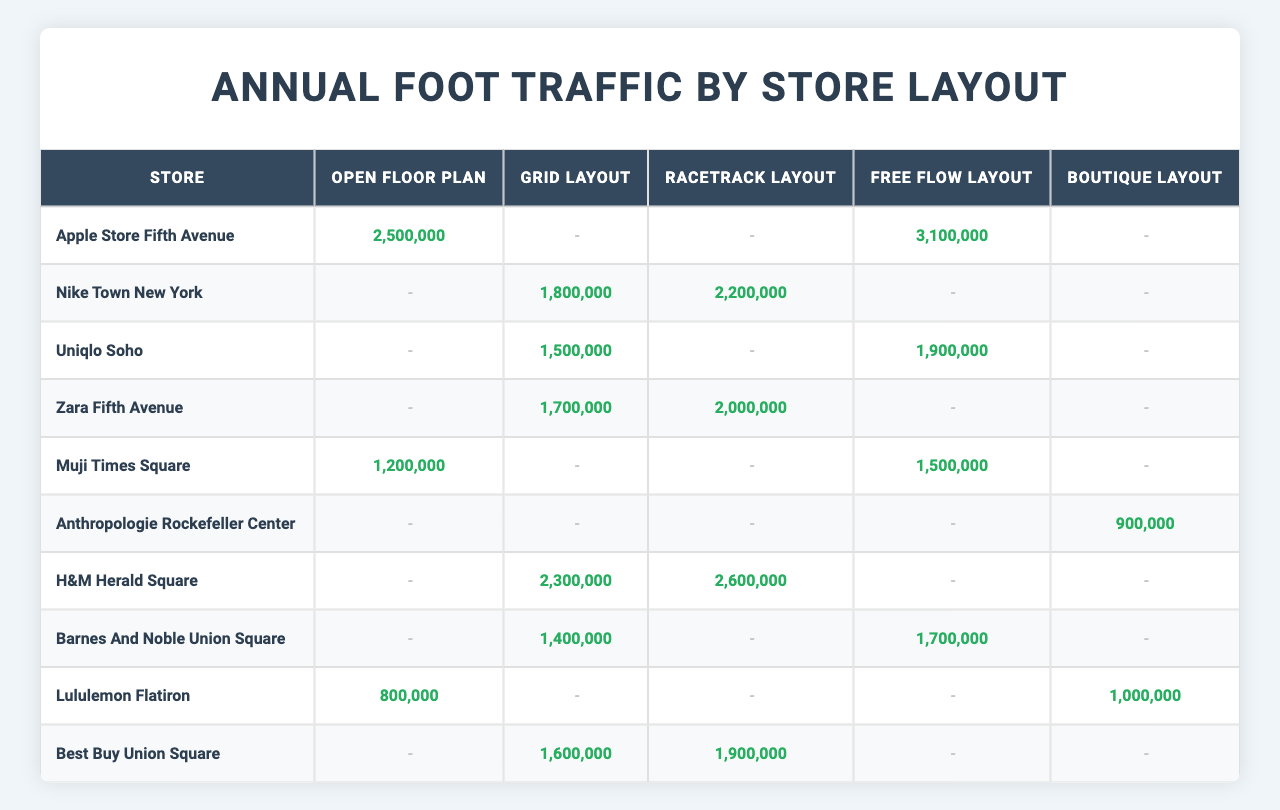What is the annual foot traffic for the Apple Store at Fifth Avenue with an Open Floor Plan? The table shows the annual foot traffic for different store layouts. For the Apple Store at Fifth Avenue, the foot traffic for the Open Floor Plan is listed as 2,500,000.
Answer: 2,500,000 Which store has the highest foot traffic in a Grid Layout? By looking at the Grid Layout column, the highest foot traffic is for H&M at Herald Square, which has 2,300,000 annual visitors.
Answer: H&M at Herald Square What is the total foot traffic for Nike Town in New York across all layouts? The foot traffic for Nike Town is 0 (Open Floor Plan) + 1,800,000 (Grid Layout) + 2,200,000 (Racetrack Layout) + 0 (Free Flow Layout) + 0 (Boutique Layout), which sums up to 4,000,000.
Answer: 4,000,000 Is the foot traffic for Zara at Fifth Avenue higher in the Racetrack Layout than in the Free Flow Layout? The foot traffic for Zara in the Racetrack Layout is 2,000,000, while in the Free Flow Layout, it is 0. Therefore, it is indeed higher in the Racetrack Layout.
Answer: Yes Which layout type has recorded foot traffic for the most stores? The Grid Layout has recorded foot traffic for 6 stores: Nike Town, Uniqlo, Zara, H&M, Barnes & Noble, and Best Buy. It's the most used layout among the stores listed in the table.
Answer: Grid Layout What is the average foot traffic for the Free Flow Layout across all stores? To find the average, sum the foot traffic for Free Flow (3,100,000 + 0 + 1,900,000 + 0 + 1,500,000 + 0 + 0 + 1,700,000 + 0 = 8,200,000) and divide by the number of stores with data (7). This gives us 8,200,000 / 7 = 1,171,428.57.
Answer: 1,171,429 Which store in the Boutique Layout has recorded any foot traffic, and what is that value? The only store with recorded foot traffic in the Boutique Layout is Anthropologie at Rockefeller Center, which has 900,000 annual visitors.
Answer: Anthropologie with 900,000 How does the foot traffic of Muji Times Square compare between the Open Floor Plan and Free Flow Layout? For Muji Times Square, the foot traffic is 1,200,000 in the Open Floor Plan and 1,500,000 in the Free Flow Layout. The Free Flow Layout has more foot traffic than the Open Floor Plan.
Answer: Free Flow Layout has more traffic 